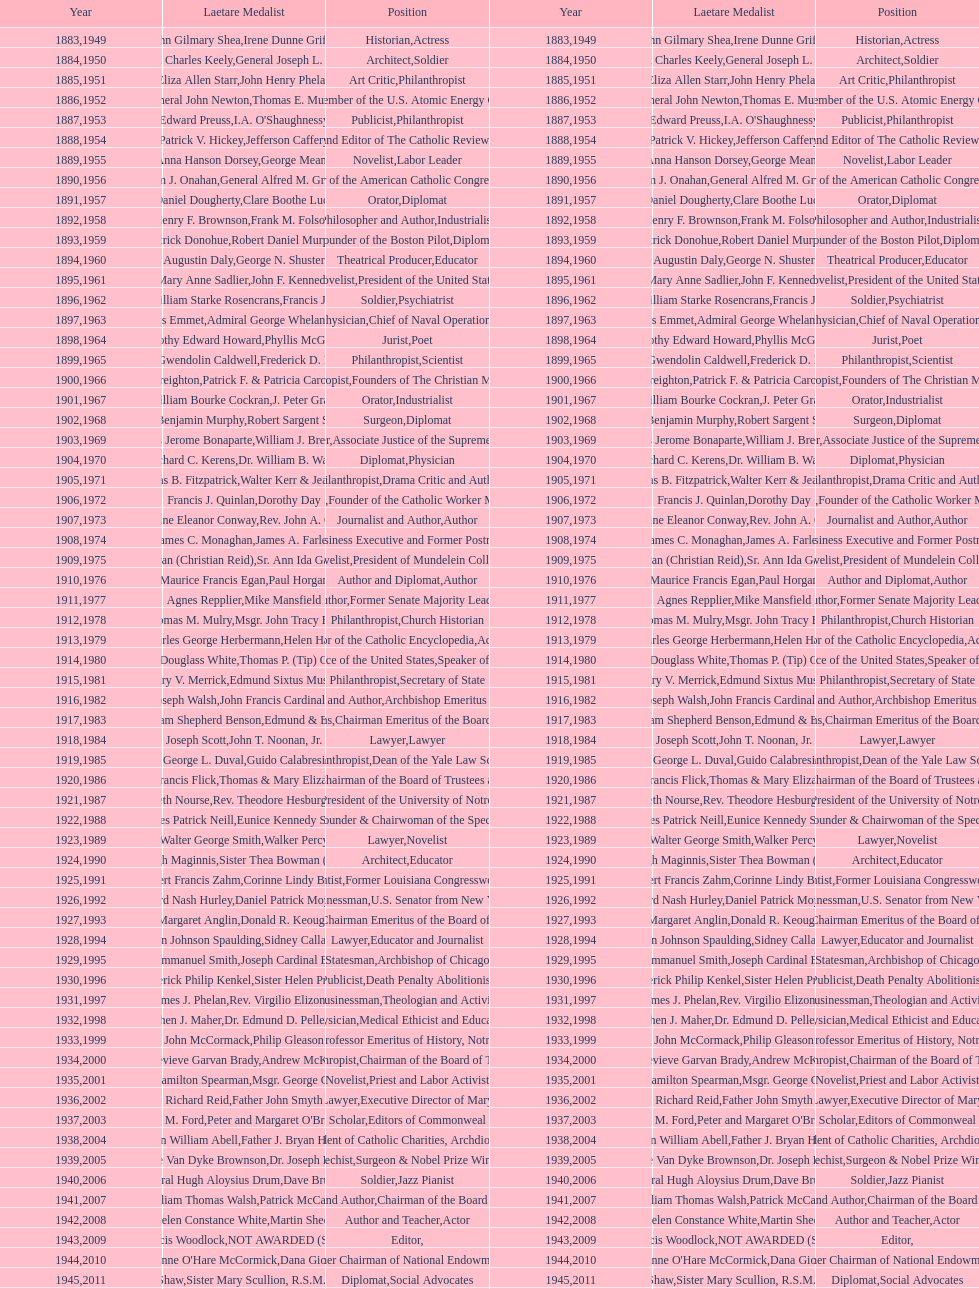What's the count of people who are or were journalists? 5. 